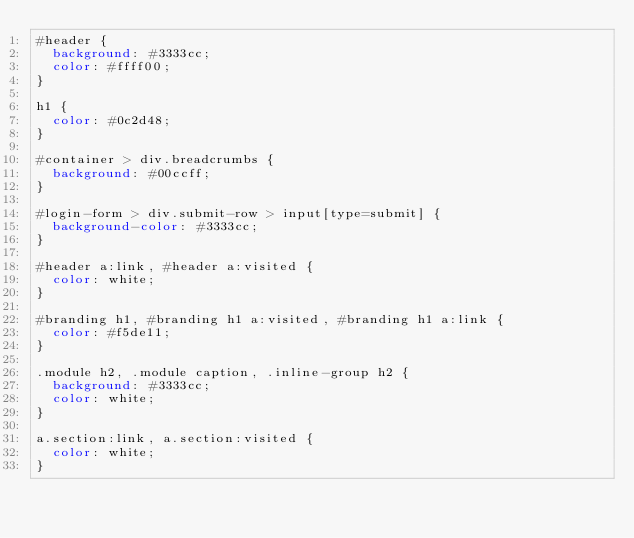<code> <loc_0><loc_0><loc_500><loc_500><_CSS_>#header {
  background: #3333cc;
  color: #ffff00;
}

h1 {
  color: #0c2d48;
}

#container > div.breadcrumbs {
  background: #00ccff;
}

#login-form > div.submit-row > input[type=submit] {
  background-color: #3333cc;
}
  
#header a:link, #header a:visited {
  color: white;
}

#branding h1, #branding h1 a:visited, #branding h1 a:link {
  color: #f5de11;
}
  
.module h2, .module caption, .inline-group h2 {
  background: #3333cc;
  color: white;
}
  
a.section:link, a.section:visited {
  color: white;
}</code> 